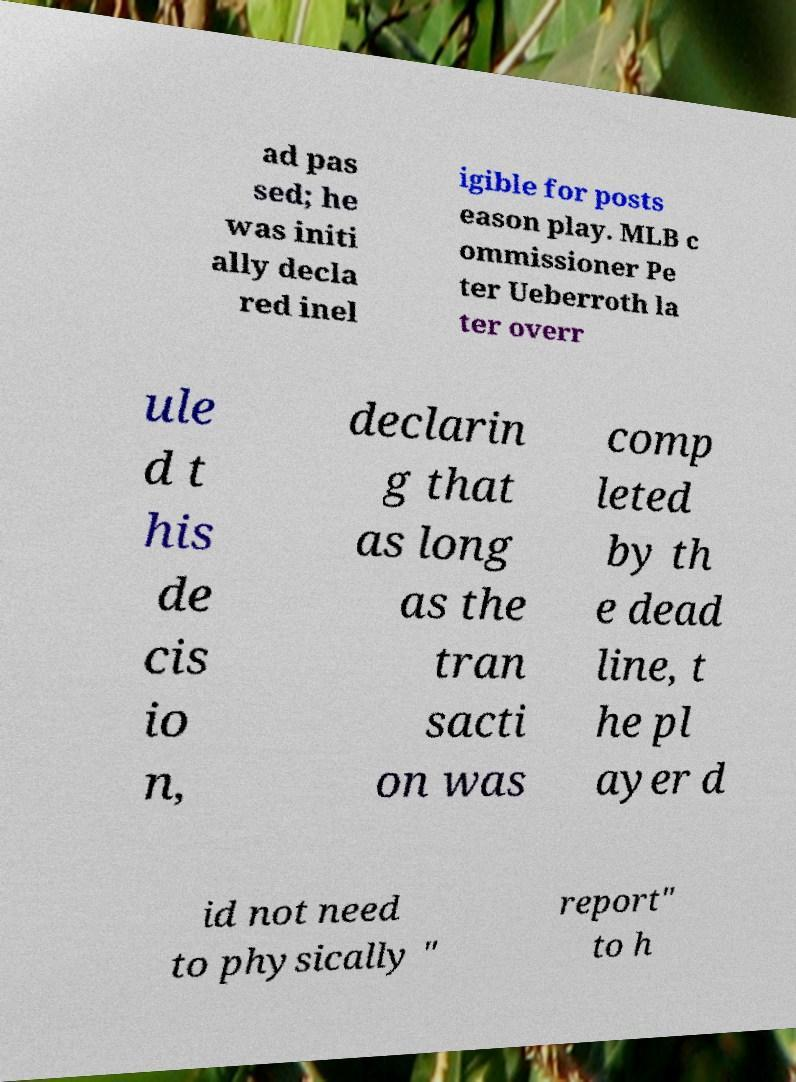I need the written content from this picture converted into text. Can you do that? ad pas sed; he was initi ally decla red inel igible for posts eason play. MLB c ommissioner Pe ter Ueberroth la ter overr ule d t his de cis io n, declarin g that as long as the tran sacti on was comp leted by th e dead line, t he pl ayer d id not need to physically " report" to h 